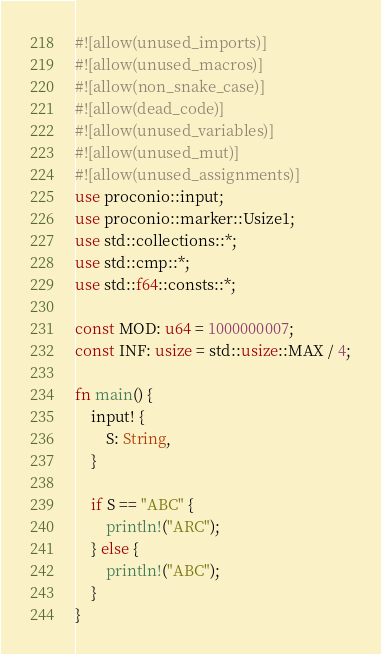Convert code to text. <code><loc_0><loc_0><loc_500><loc_500><_Rust_>#![allow(unused_imports)]
#![allow(unused_macros)]
#![allow(non_snake_case)]
#![allow(dead_code)]
#![allow(unused_variables)]
#![allow(unused_mut)]
#![allow(unused_assignments)]
use proconio::input;
use proconio::marker::Usize1;
use std::collections::*;
use std::cmp::*;
use std::f64::consts::*;

const MOD: u64 = 1000000007;
const INF: usize = std::usize::MAX / 4;

fn main() {
    input! {
        S: String,
    }

    if S == "ABC" {
        println!("ARC");
    } else {
        println!("ABC");
    }
}
</code> 